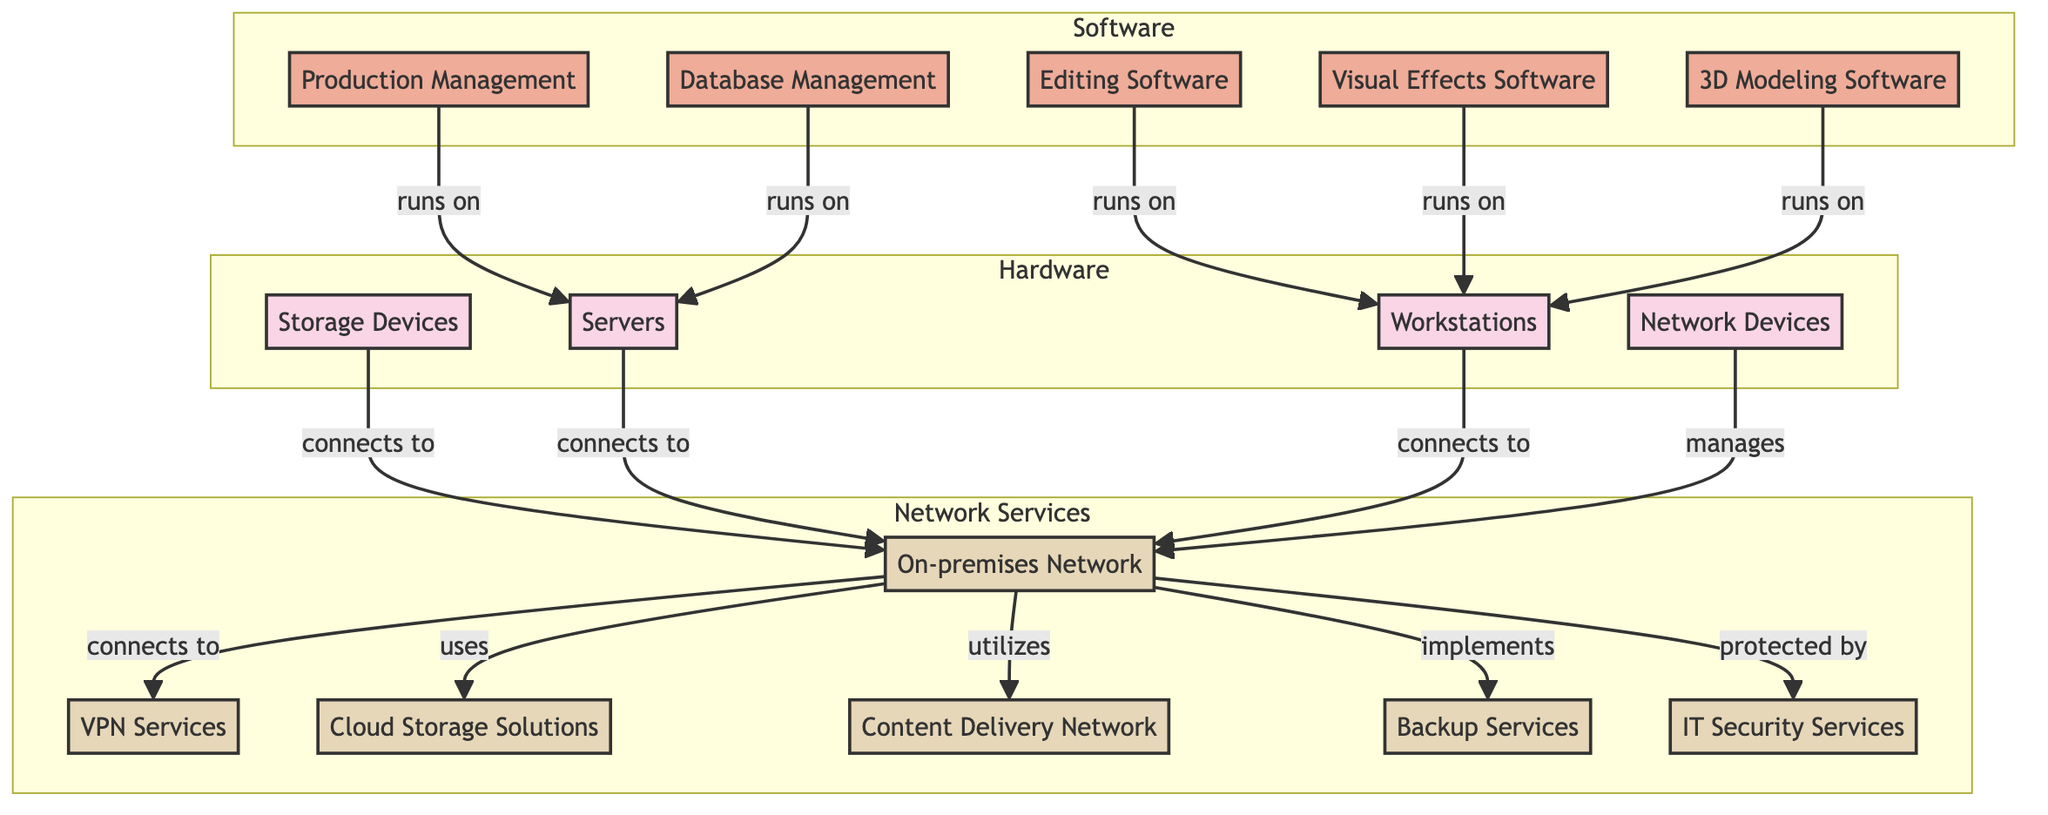What are the types of Hardware depicted in the diagram? The diagram features a specific subgraph labeled "Hardware," which includes Storage Devices, Servers, Workstations, and Network Devices. By identifying these nodes within the subgraph, we can enumerate the types.
Answer: Storage Devices, Servers, Workstations, Network Devices How many types of Editing Software are listed in the diagram? Within the subgraph labeled "Software," the section for Editing Software lists two specific items: Adobe Premiere Pro and Final Cut Pro. Counting these gives us the total number of types.
Answer: 2 What main service does the On-premises Network connect to? The diagram illustrates that the On-premises Network, indicated by the node labeled "ON," has several arrows stemming from it. One of these arrows leads to the node "VPN Services," indicating a direct connection. This establishes that VPN Services is a primary connection for the ON node.
Answer: VPN Services How many software categories are illustrated in the diagram? The diagram contains a subgraph titled "Software" that lists five distinct software categories: Editing Software, Visual Effects Software, 3D Modeling Software, Production Management, and Database Management. By counting these categories, we find the total number present.
Answer: 5 Which hardware element is connected to the IT Security Services? The diagram shows that the IT Security Services node is not directly connected to any specific hardware elements. However, it is part of the overall network services protecting the On-premises Network, as indicated by the arrow connecting it. Thus, the answer must reference the broader network elements instead of specific hardware elements.
Answer: On-premises Network Which software type is used to run on Servers in the diagram? The diagram indicates that both Production Management and Database Management software run on the Servers, indicated by directional arrows. By examining the nodes connected to "SV" (Servers), we can determine the applicable software types.
Answer: Production Management, Database Management What type of Network Service utilizes Cloud Storage Solutions? The diagram shows that Cloud Storage Solutions connect directly to the On-premises Network node, which implies that it is utilized as a service supported by the network. By reviewing the connections from the ON node, we can confirm this relationship.
Answer: Cloud Storage Solutions How many different types of Workstations are represented? In the subgraph labeled "Hardware," the Workstations category identifies three types: Editing Workstations, 3D Modeling Workstations, and Visual Effects Workstations. By counting these specific types, we ascertain the total.
Answer: 3 What connects the Server category to the On-premises Network? The diagram demonstrates that both database servers and file servers have directional arrows leading to the On-premises Network node. This relationship confirms that these servers connect directly to the ON node in the infrastructure.
Answer: Server category 